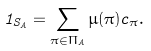Convert formula to latex. <formula><loc_0><loc_0><loc_500><loc_500>1 _ { S _ { A } } = \sum _ { \pi \in \Pi _ { A } } \mu ( \pi ) c _ { \pi } .</formula> 